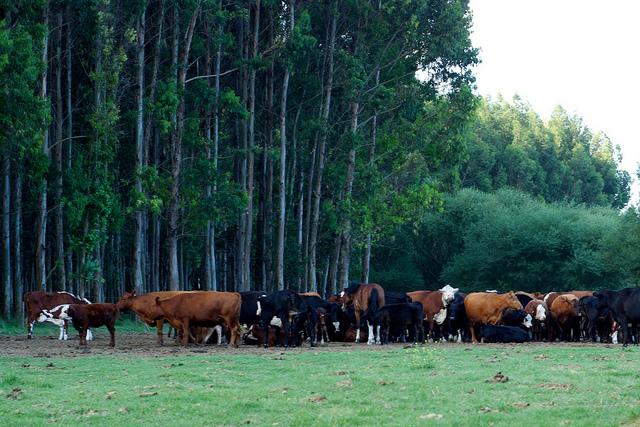Are these cattle in a zoo?
Write a very short answer. No. Is there more than 10 cows?
Write a very short answer. Yes. How many cows are under this tree?
Quick response, please. Many. Do cattle graze all day?
Concise answer only. Yes. What time of day is it?
Give a very brief answer. Morning. 